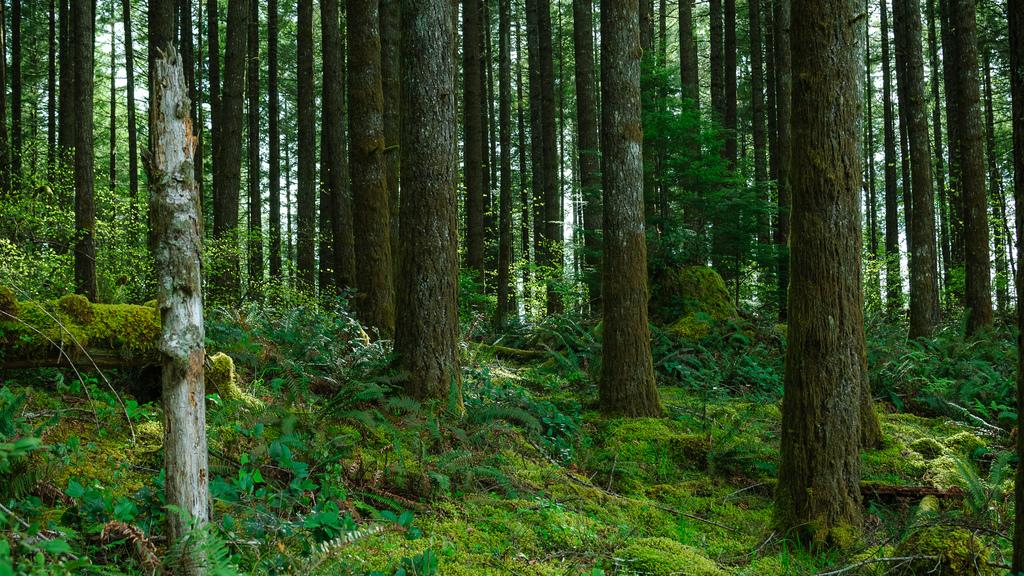What type of living organisms can be seen in the image? Plants and trees are visible in the image. Can you describe the specific types of plants and trees in the image? The provided facts do not specify the types of plants and trees in the image. What type of cream is being used to paint the color onto the aunt's portrait in the image? There is no reference to cream, color, or an aunt in the image, so it is not possible to answer that question. 